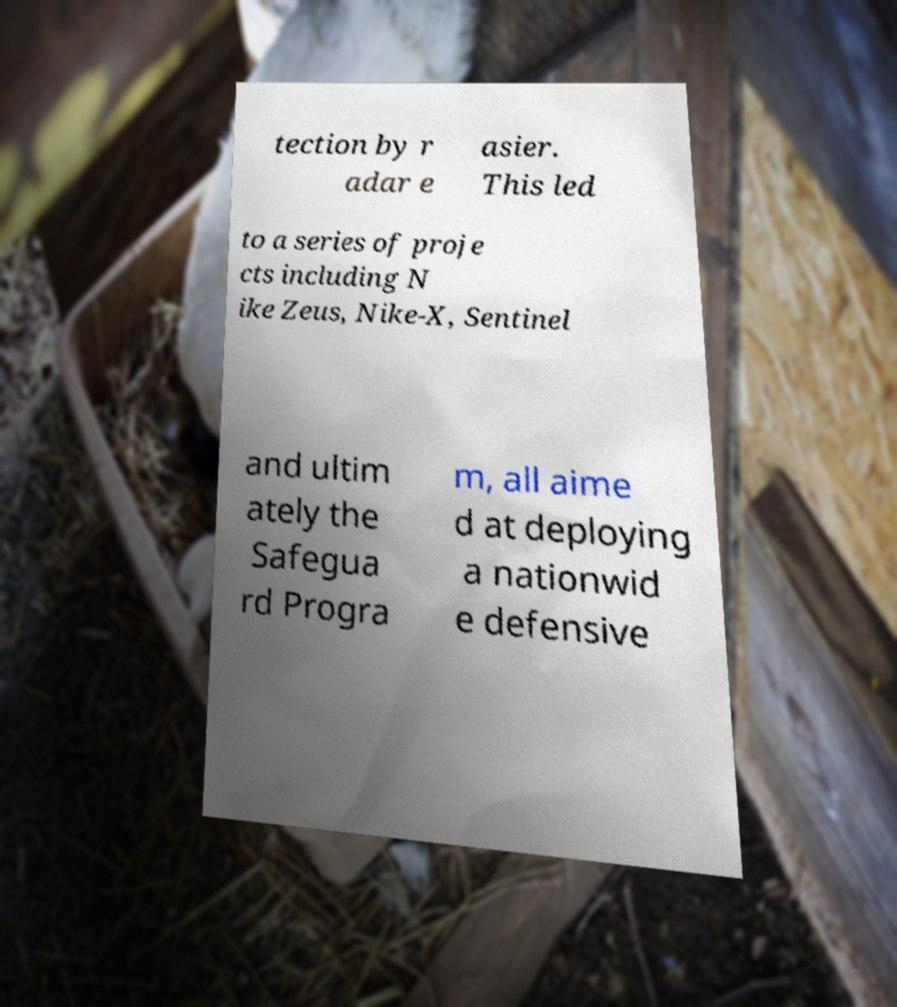Could you assist in decoding the text presented in this image and type it out clearly? tection by r adar e asier. This led to a series of proje cts including N ike Zeus, Nike-X, Sentinel and ultim ately the Safegua rd Progra m, all aime d at deploying a nationwid e defensive 